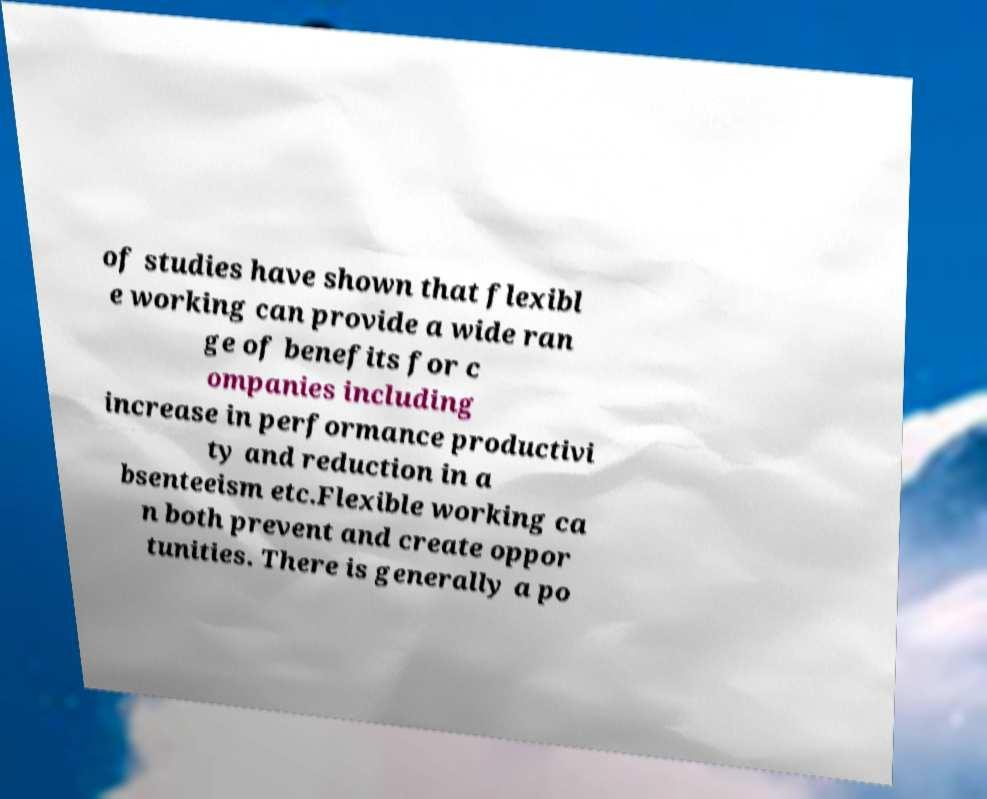For documentation purposes, I need the text within this image transcribed. Could you provide that? of studies have shown that flexibl e working can provide a wide ran ge of benefits for c ompanies including increase in performance productivi ty and reduction in a bsenteeism etc.Flexible working ca n both prevent and create oppor tunities. There is generally a po 